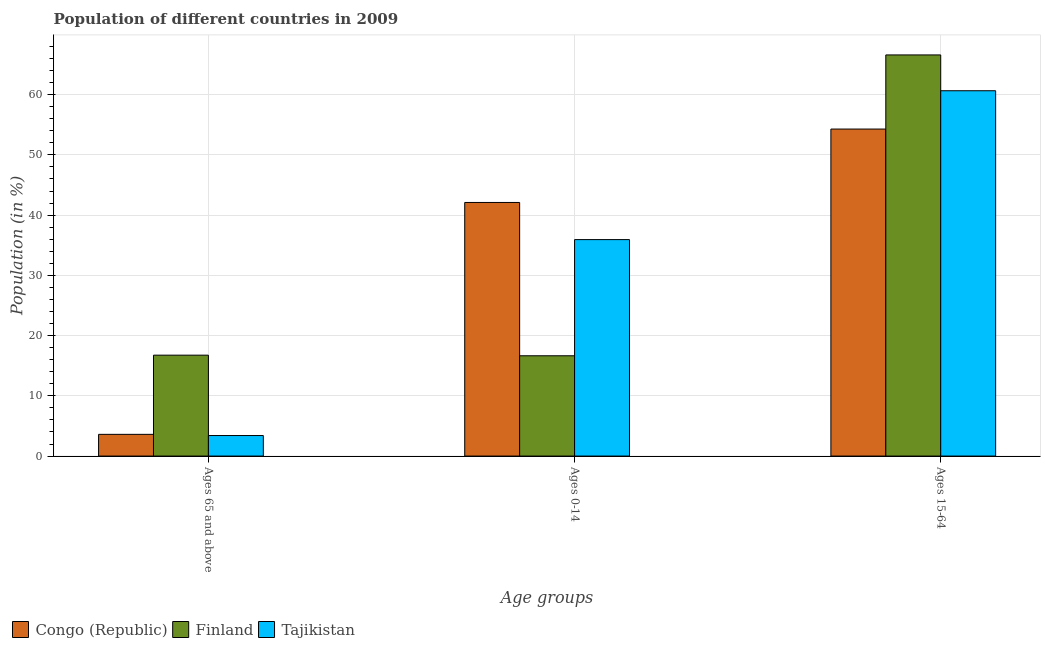How many different coloured bars are there?
Your answer should be very brief. 3. How many groups of bars are there?
Offer a very short reply. 3. What is the label of the 3rd group of bars from the left?
Provide a succinct answer. Ages 15-64. What is the percentage of population within the age-group of 65 and above in Tajikistan?
Provide a short and direct response. 3.41. Across all countries, what is the maximum percentage of population within the age-group 0-14?
Offer a terse response. 42.11. Across all countries, what is the minimum percentage of population within the age-group 0-14?
Ensure brevity in your answer.  16.65. In which country was the percentage of population within the age-group 0-14 maximum?
Give a very brief answer. Congo (Republic). What is the total percentage of population within the age-group 15-64 in the graph?
Provide a succinct answer. 181.54. What is the difference between the percentage of population within the age-group 15-64 in Congo (Republic) and that in Tajikistan?
Your response must be concise. -6.36. What is the difference between the percentage of population within the age-group 15-64 in Tajikistan and the percentage of population within the age-group of 65 and above in Finland?
Offer a terse response. 43.9. What is the average percentage of population within the age-group 0-14 per country?
Ensure brevity in your answer.  31.56. What is the difference between the percentage of population within the age-group of 65 and above and percentage of population within the age-group 15-64 in Tajikistan?
Keep it short and to the point. -57.24. What is the ratio of the percentage of population within the age-group of 65 and above in Tajikistan to that in Finland?
Your answer should be very brief. 0.2. Is the percentage of population within the age-group 0-14 in Tajikistan less than that in Congo (Republic)?
Provide a succinct answer. Yes. What is the difference between the highest and the second highest percentage of population within the age-group 15-64?
Keep it short and to the point. 5.94. What is the difference between the highest and the lowest percentage of population within the age-group 15-64?
Offer a very short reply. 12.31. Is the sum of the percentage of population within the age-group 15-64 in Congo (Republic) and Tajikistan greater than the maximum percentage of population within the age-group 0-14 across all countries?
Make the answer very short. Yes. What does the 3rd bar from the left in Ages 65 and above represents?
Offer a very short reply. Tajikistan. What does the 1st bar from the right in Ages 15-64 represents?
Make the answer very short. Tajikistan. Is it the case that in every country, the sum of the percentage of population within the age-group of 65 and above and percentage of population within the age-group 0-14 is greater than the percentage of population within the age-group 15-64?
Make the answer very short. No. Are all the bars in the graph horizontal?
Your answer should be very brief. No. What is the difference between two consecutive major ticks on the Y-axis?
Give a very brief answer. 10. Where does the legend appear in the graph?
Make the answer very short. Bottom left. How are the legend labels stacked?
Keep it short and to the point. Horizontal. What is the title of the graph?
Provide a succinct answer. Population of different countries in 2009. What is the label or title of the X-axis?
Your answer should be very brief. Age groups. What is the label or title of the Y-axis?
Provide a succinct answer. Population (in %). What is the Population (in %) in Congo (Republic) in Ages 65 and above?
Make the answer very short. 3.6. What is the Population (in %) of Finland in Ages 65 and above?
Make the answer very short. 16.75. What is the Population (in %) of Tajikistan in Ages 65 and above?
Your answer should be compact. 3.41. What is the Population (in %) in Congo (Republic) in Ages 0-14?
Ensure brevity in your answer.  42.11. What is the Population (in %) of Finland in Ages 0-14?
Offer a terse response. 16.65. What is the Population (in %) of Tajikistan in Ages 0-14?
Ensure brevity in your answer.  35.94. What is the Population (in %) in Congo (Republic) in Ages 15-64?
Provide a succinct answer. 54.29. What is the Population (in %) in Finland in Ages 15-64?
Make the answer very short. 66.6. What is the Population (in %) in Tajikistan in Ages 15-64?
Provide a short and direct response. 60.65. Across all Age groups, what is the maximum Population (in %) in Congo (Republic)?
Make the answer very short. 54.29. Across all Age groups, what is the maximum Population (in %) of Finland?
Provide a short and direct response. 66.6. Across all Age groups, what is the maximum Population (in %) of Tajikistan?
Provide a succinct answer. 60.65. Across all Age groups, what is the minimum Population (in %) of Congo (Republic)?
Provide a short and direct response. 3.6. Across all Age groups, what is the minimum Population (in %) in Finland?
Provide a short and direct response. 16.65. Across all Age groups, what is the minimum Population (in %) in Tajikistan?
Provide a succinct answer. 3.41. What is the total Population (in %) in Congo (Republic) in the graph?
Ensure brevity in your answer.  100. What is the total Population (in %) of Tajikistan in the graph?
Ensure brevity in your answer.  100. What is the difference between the Population (in %) in Congo (Republic) in Ages 65 and above and that in Ages 0-14?
Offer a very short reply. -38.5. What is the difference between the Population (in %) in Finland in Ages 65 and above and that in Ages 0-14?
Make the answer very short. 0.1. What is the difference between the Population (in %) in Tajikistan in Ages 65 and above and that in Ages 0-14?
Your response must be concise. -32.53. What is the difference between the Population (in %) in Congo (Republic) in Ages 65 and above and that in Ages 15-64?
Offer a terse response. -50.69. What is the difference between the Population (in %) of Finland in Ages 65 and above and that in Ages 15-64?
Provide a succinct answer. -49.85. What is the difference between the Population (in %) of Tajikistan in Ages 65 and above and that in Ages 15-64?
Offer a very short reply. -57.24. What is the difference between the Population (in %) of Congo (Republic) in Ages 0-14 and that in Ages 15-64?
Provide a succinct answer. -12.18. What is the difference between the Population (in %) in Finland in Ages 0-14 and that in Ages 15-64?
Provide a succinct answer. -49.95. What is the difference between the Population (in %) in Tajikistan in Ages 0-14 and that in Ages 15-64?
Your response must be concise. -24.71. What is the difference between the Population (in %) in Congo (Republic) in Ages 65 and above and the Population (in %) in Finland in Ages 0-14?
Give a very brief answer. -13.05. What is the difference between the Population (in %) of Congo (Republic) in Ages 65 and above and the Population (in %) of Tajikistan in Ages 0-14?
Give a very brief answer. -32.33. What is the difference between the Population (in %) of Finland in Ages 65 and above and the Population (in %) of Tajikistan in Ages 0-14?
Keep it short and to the point. -19.19. What is the difference between the Population (in %) of Congo (Republic) in Ages 65 and above and the Population (in %) of Finland in Ages 15-64?
Your answer should be compact. -62.99. What is the difference between the Population (in %) of Congo (Republic) in Ages 65 and above and the Population (in %) of Tajikistan in Ages 15-64?
Your response must be concise. -57.05. What is the difference between the Population (in %) in Finland in Ages 65 and above and the Population (in %) in Tajikistan in Ages 15-64?
Provide a short and direct response. -43.9. What is the difference between the Population (in %) of Congo (Republic) in Ages 0-14 and the Population (in %) of Finland in Ages 15-64?
Keep it short and to the point. -24.49. What is the difference between the Population (in %) in Congo (Republic) in Ages 0-14 and the Population (in %) in Tajikistan in Ages 15-64?
Provide a succinct answer. -18.55. What is the difference between the Population (in %) of Finland in Ages 0-14 and the Population (in %) of Tajikistan in Ages 15-64?
Offer a very short reply. -44. What is the average Population (in %) in Congo (Republic) per Age groups?
Offer a very short reply. 33.33. What is the average Population (in %) of Finland per Age groups?
Offer a very short reply. 33.33. What is the average Population (in %) of Tajikistan per Age groups?
Give a very brief answer. 33.33. What is the difference between the Population (in %) in Congo (Republic) and Population (in %) in Finland in Ages 65 and above?
Your answer should be compact. -13.15. What is the difference between the Population (in %) in Congo (Republic) and Population (in %) in Tajikistan in Ages 65 and above?
Keep it short and to the point. 0.2. What is the difference between the Population (in %) in Finland and Population (in %) in Tajikistan in Ages 65 and above?
Offer a very short reply. 13.34. What is the difference between the Population (in %) of Congo (Republic) and Population (in %) of Finland in Ages 0-14?
Provide a short and direct response. 25.45. What is the difference between the Population (in %) of Congo (Republic) and Population (in %) of Tajikistan in Ages 0-14?
Your answer should be compact. 6.17. What is the difference between the Population (in %) of Finland and Population (in %) of Tajikistan in Ages 0-14?
Your response must be concise. -19.29. What is the difference between the Population (in %) in Congo (Republic) and Population (in %) in Finland in Ages 15-64?
Your response must be concise. -12.31. What is the difference between the Population (in %) of Congo (Republic) and Population (in %) of Tajikistan in Ages 15-64?
Offer a terse response. -6.36. What is the difference between the Population (in %) of Finland and Population (in %) of Tajikistan in Ages 15-64?
Provide a succinct answer. 5.94. What is the ratio of the Population (in %) in Congo (Republic) in Ages 65 and above to that in Ages 0-14?
Offer a terse response. 0.09. What is the ratio of the Population (in %) in Tajikistan in Ages 65 and above to that in Ages 0-14?
Your answer should be very brief. 0.09. What is the ratio of the Population (in %) in Congo (Republic) in Ages 65 and above to that in Ages 15-64?
Ensure brevity in your answer.  0.07. What is the ratio of the Population (in %) in Finland in Ages 65 and above to that in Ages 15-64?
Offer a terse response. 0.25. What is the ratio of the Population (in %) of Tajikistan in Ages 65 and above to that in Ages 15-64?
Make the answer very short. 0.06. What is the ratio of the Population (in %) of Congo (Republic) in Ages 0-14 to that in Ages 15-64?
Provide a short and direct response. 0.78. What is the ratio of the Population (in %) of Tajikistan in Ages 0-14 to that in Ages 15-64?
Provide a short and direct response. 0.59. What is the difference between the highest and the second highest Population (in %) in Congo (Republic)?
Keep it short and to the point. 12.18. What is the difference between the highest and the second highest Population (in %) of Finland?
Your answer should be compact. 49.85. What is the difference between the highest and the second highest Population (in %) of Tajikistan?
Provide a succinct answer. 24.71. What is the difference between the highest and the lowest Population (in %) in Congo (Republic)?
Give a very brief answer. 50.69. What is the difference between the highest and the lowest Population (in %) of Finland?
Provide a short and direct response. 49.95. What is the difference between the highest and the lowest Population (in %) in Tajikistan?
Provide a succinct answer. 57.24. 